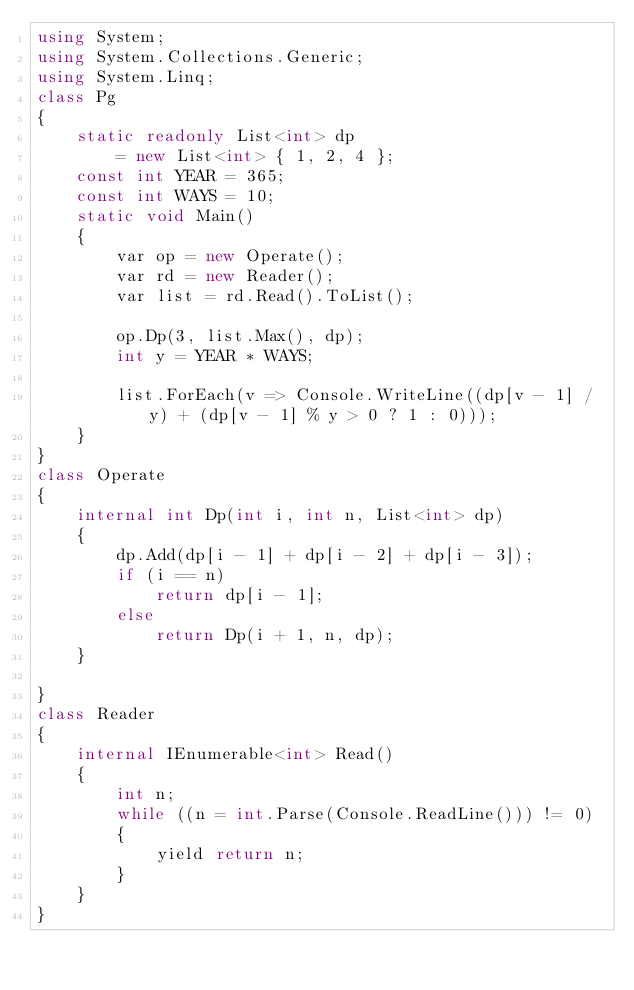<code> <loc_0><loc_0><loc_500><loc_500><_C#_>using System;
using System.Collections.Generic;
using System.Linq;
class Pg
{
    static readonly List<int> dp
        = new List<int> { 1, 2, 4 };
    const int YEAR = 365;
    const int WAYS = 10;
    static void Main()
    {
        var op = new Operate();
        var rd = new Reader();
        var list = rd.Read().ToList();

        op.Dp(3, list.Max(), dp);
        int y = YEAR * WAYS;

        list.ForEach(v => Console.WriteLine((dp[v - 1] / y) + (dp[v - 1] % y > 0 ? 1 : 0)));
    }
}
class Operate
{
    internal int Dp(int i, int n, List<int> dp)
    {
        dp.Add(dp[i - 1] + dp[i - 2] + dp[i - 3]);
        if (i == n)
            return dp[i - 1];
        else
            return Dp(i + 1, n, dp);
    }

}
class Reader
{
    internal IEnumerable<int> Read()
    {
        int n;
        while ((n = int.Parse(Console.ReadLine())) != 0)
        {
            yield return n;
        }
    }
}
</code> 